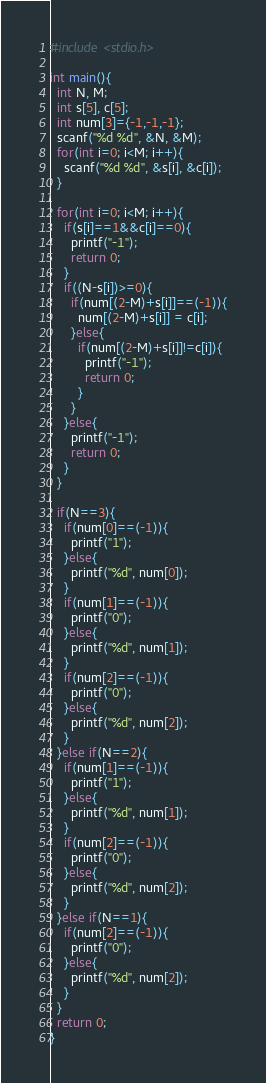<code> <loc_0><loc_0><loc_500><loc_500><_C_>#include <stdio.h>
 
int main(){
  int N, M;
  int s[5], c[5];
  int num[3]={-1,-1,-1};
  scanf("%d %d", &N, &M);
  for(int i=0; i<M; i++){
    scanf("%d %d", &s[i], &c[i]);
  }
  
  for(int i=0; i<M; i++){
    if(s[i]==1&&c[i]==0){
      printf("-1");
      return 0;
    }
    if((N-s[i])>=0){
      if(num[(2-M)+s[i]]==(-1)){
        num[(2-M)+s[i]] = c[i];
      }else{
        if(num[(2-M)+s[i]]!=c[i]){
          printf("-1");
          return 0;
        }
      }
    }else{
      printf("-1");
      return 0;
    }
  }
 
  if(N==3){
    if(num[0]==(-1)){
      printf("1");
    }else{
      printf("%d", num[0]);
    }
    if(num[1]==(-1)){
      printf("0");
    }else{
      printf("%d", num[1]);
    }
    if(num[2]==(-1)){
      printf("0");
    }else{
      printf("%d", num[2]);
    }
  }else if(N==2){
    if(num[1]==(-1)){
      printf("1");
    }else{
      printf("%d", num[1]);
    }
    if(num[2]==(-1)){
      printf("0");
    }else{
      printf("%d", num[2]);
    }
  }else if(N==1){
    if(num[2]==(-1)){
      printf("0");
    }else{
      printf("%d", num[2]);
    }
  }
  return 0;
}</code> 